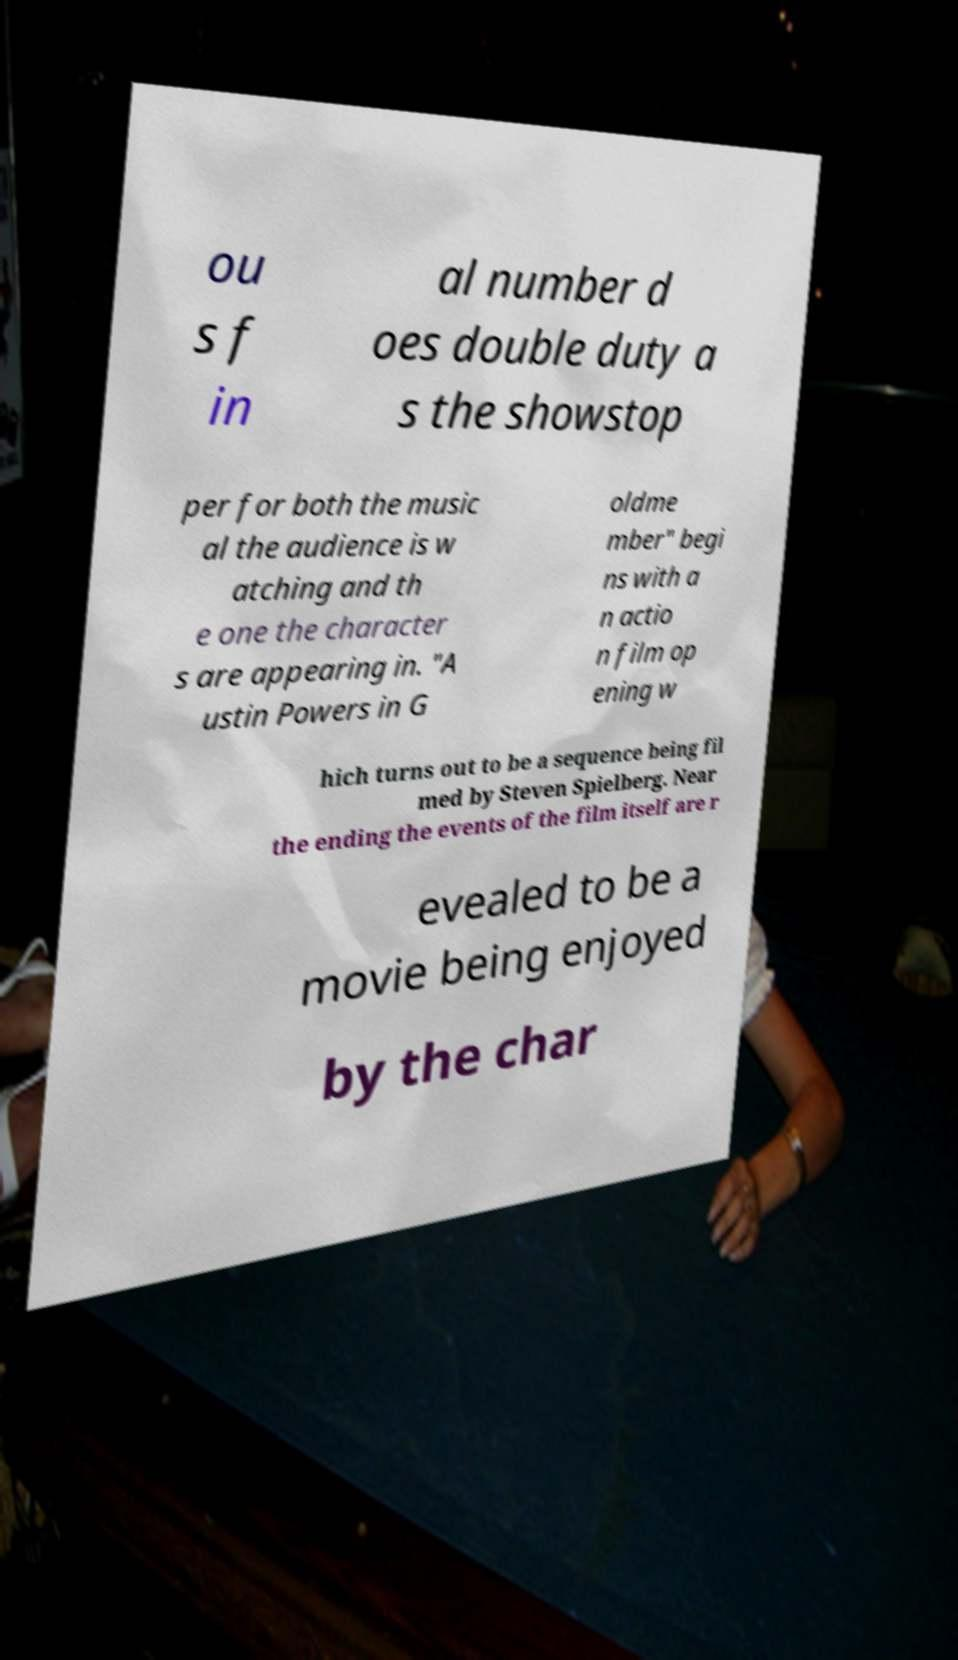Please identify and transcribe the text found in this image. ou s f in al number d oes double duty a s the showstop per for both the music al the audience is w atching and th e one the character s are appearing in. "A ustin Powers in G oldme mber" begi ns with a n actio n film op ening w hich turns out to be a sequence being fil med by Steven Spielberg. Near the ending the events of the film itself are r evealed to be a movie being enjoyed by the char 